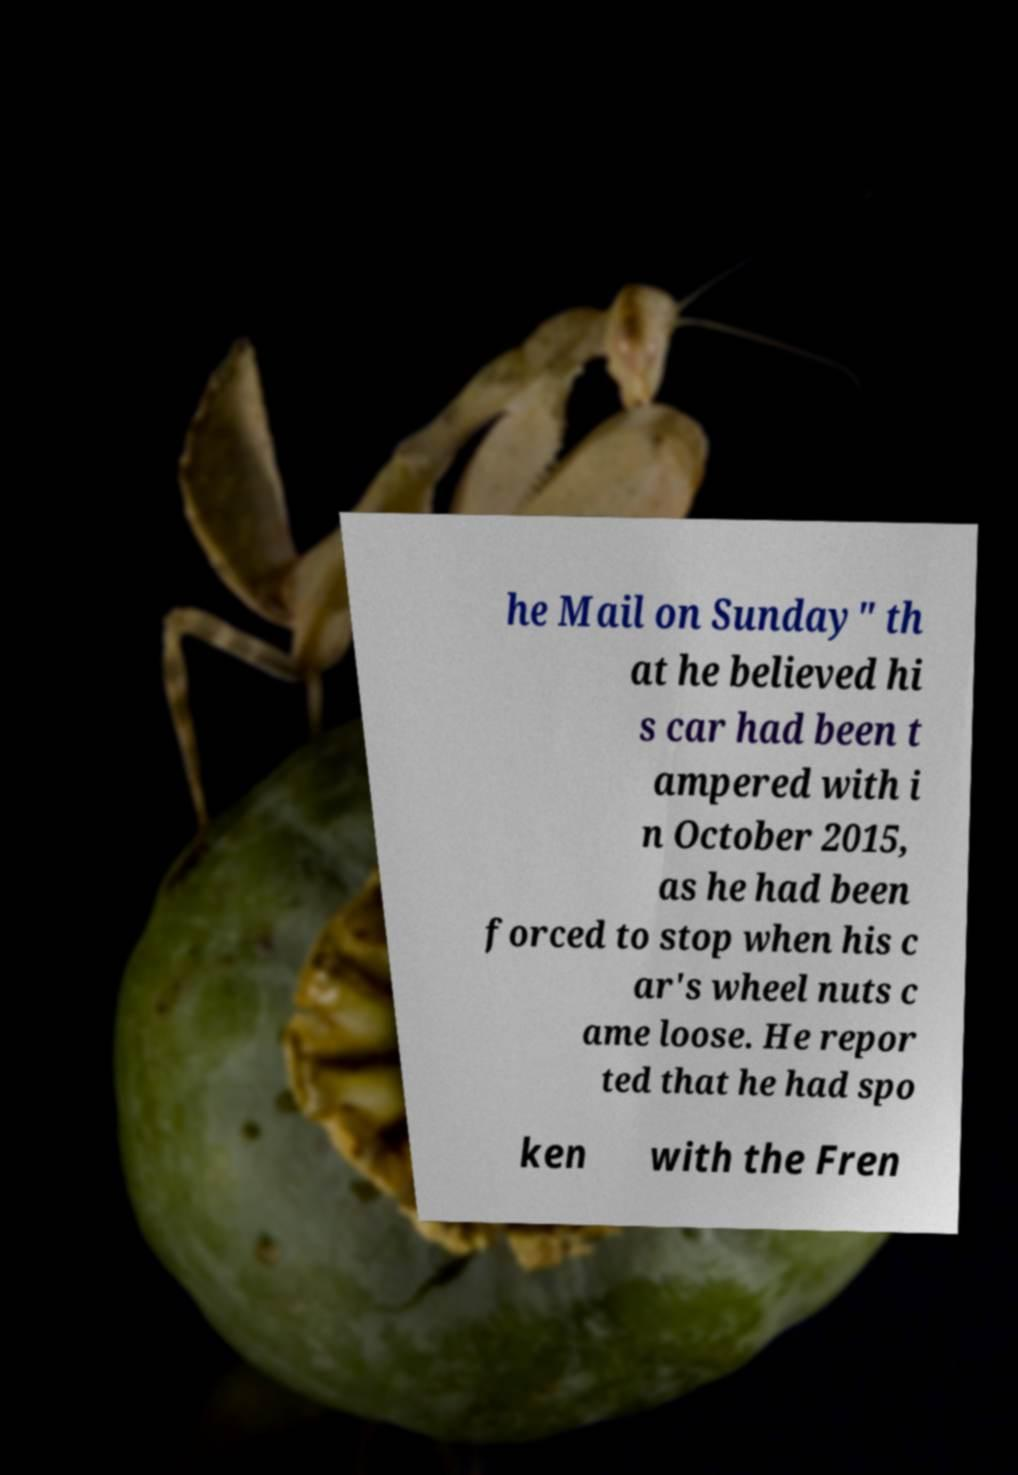Please read and relay the text visible in this image. What does it say? he Mail on Sunday" th at he believed hi s car had been t ampered with i n October 2015, as he had been forced to stop when his c ar's wheel nuts c ame loose. He repor ted that he had spo ken with the Fren 